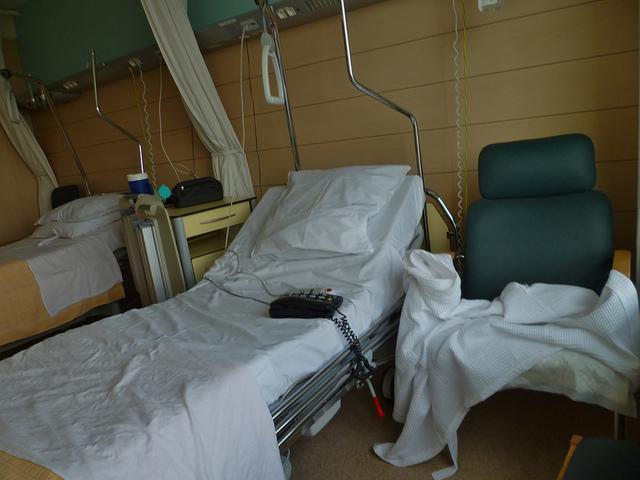Why does the bed have a lever?
Keep it brief. Hospital bed. What color is the lever under the bed?
Write a very short answer. Red. Is this a hospital?
Short answer required. Yes. 